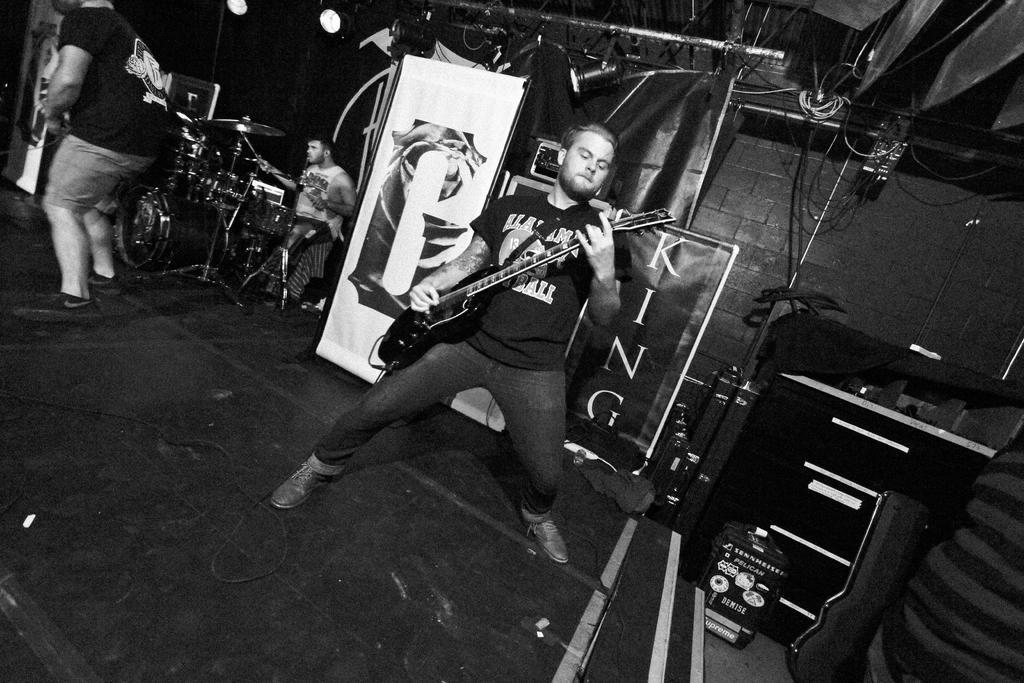Can you describe this image briefly? In this image there are three people. The person in the middle is standing and playing guitar, the person at the back sitting and playing drums, the person standing at the left is playing guitar. At the top there are lights, and at the right side of the image there are speakers, at the back there is a banner. 